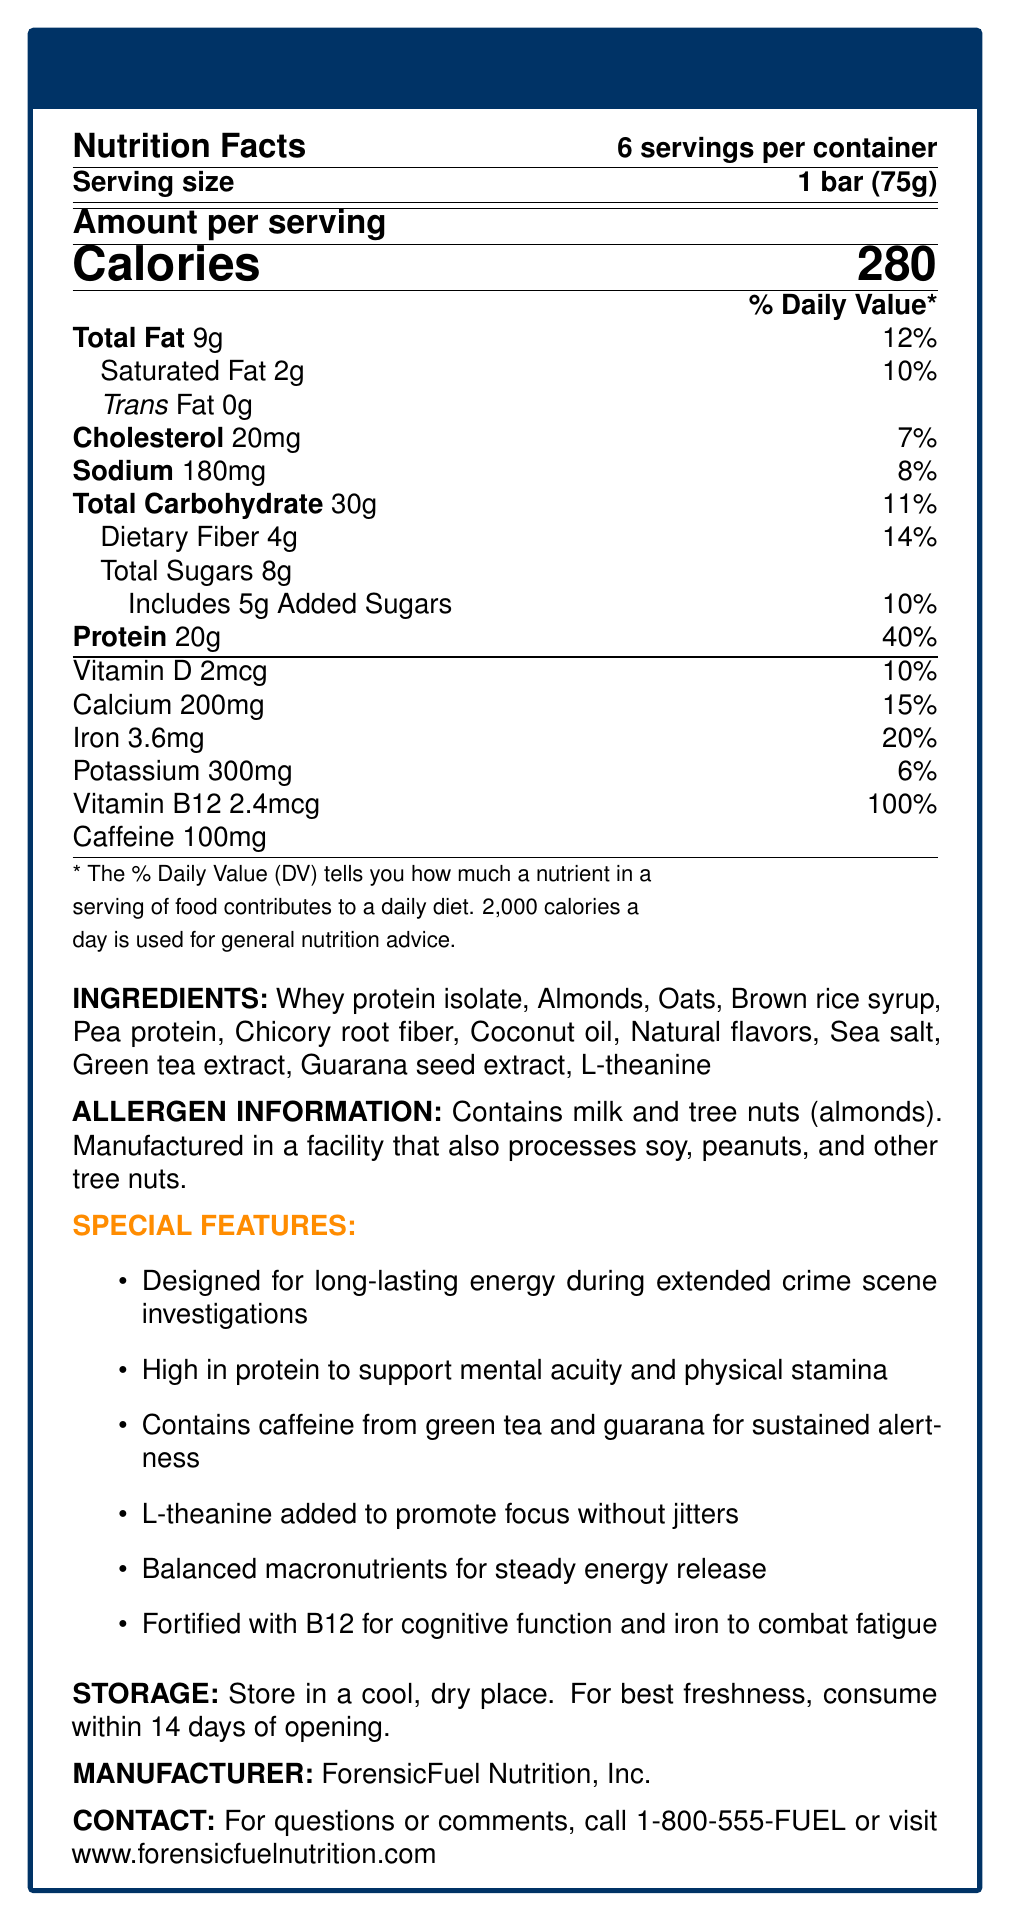what is the serving size of the CrimeBuster Energy Bar? The serving size is explicitly mentioned as "1 bar (75g)" in the nutrition facts.
Answer: 1 bar (75g) how many calories are there per serving? The document clearly states the amount of calories per serving as 280.
Answer: 280 how much protein is in each bar, and what percentage of the daily value does it represent? Each bar contains 20g of protein, which represents 40% of the daily value.
Answer: 20g, 40% what are the total fat and saturated fat contents per serving? The nutrition facts list total fat as 9g and saturated fat as 2g.
Answer: Total Fat: 9g, Saturated Fat: 2g which vitamins and minerals are highlighted on the label? The label lists Vitamin D, Calcium, Iron, Potassium, and Vitamin B12 with their respective amounts and daily values.
Answer: Vitamin D, Calcium, Iron, Potassium, Vitamin B12 how many grams of total sugars and added sugars does each bar contain? The bar contains 8g of total sugars and 5g of added sugars.
Answer: Total Sugars: 8g, Added Sugars: 5g what ingredient is listed first, and why might it be significant? Ingredients are usually listed in order of predominance, so whey protein isolate is likely the main ingredient.
Answer: Whey protein isolate which of the following is NOT an ingredient in the CrimeBuster Energy Bar? A. Almonds B. Oats C. Soy Protein D. Chicory Root Fiber "Soy protein" is not listed among the ingredients, while the other options are.
Answer: C. Soy Protein what is the amount of caffeine per serving, and from which sources is it derived? A. 50mg, Coffee B. 100mg, Green tea and Guarana C. 150mg, Yerba Mate D. 200mg, Black Tea The label states that there is 100mg of caffeine derived from green tea and guarana.
Answer: B. 100mg, Green tea and Guarana does the CrimeBuster Energy Bar contain any trans fats? The document indicates that the bar contains 0g of trans fats.
Answer: No is this product suitable for someone with a peanut allergy? The allergen information states that it is manufactured in a facility that processes soy, peanuts, and other tree nuts.
Answer: No what is the primary purpose of this energy bar according to the special features? The special features highlight that it is designed for long-lasting energy during extended crime scene investigations.
Answer: Long-lasting energy during extended crime scene investigations which feature helps enhance cognitive function and mental acuity? The document mentions that high protein supports mental acuity and Vitamin B12 aids cognitive function.
Answer: High protein, Vitamin B12 who manufactures the CrimeBuster Energy Bar? The manufacturer is listed as ForensicFuel Nutrition, Inc.
Answer: ForensicFuel Nutrition, Inc. if a crime scene investigator eats two bars in one shift, how many calories will they consume? Each bar contains 280 calories, so two bars equal 560 calories (280 calories x 2).
Answer: 560 calories how should the CrimeBuster Energy Bar be stored for optimal freshness? The storage instructions specify to store in a cool, dry place and consume within 14 days of opening.
Answer: Store in a cool, dry place. Consume within 14 days of opening. summarize the main features of the CrimeBuster Energy Bar. The summary covers the primary purpose and key components that aid in sustained energy, mental focus, and nutrition for crime scene tasks.
Answer: The CrimeBuster Energy Bar is a high-protein energy bar designed for crime scene investigators, providing long-lasting energy and mental focus. It contains essential nutrients, caffeine, and ingredients like whey protein and guarana. The bar also includes vitamins B12 and iron to support cognitive function and combat fatigue. what are the exact amounts of iron and potassium in each serving? The nutrition facts indicate that each serving contains 3.6mg of iron and 300mg of potassium.
Answer: Iron: 3.6mg, Potassium: 300mg how frequently should one consume the CrimeBuster Energy Bar to achieve the designed long-lasting energy effect? The document does not specify how frequently one should consume the bars for maximum effect.
Answer: Not enough information 